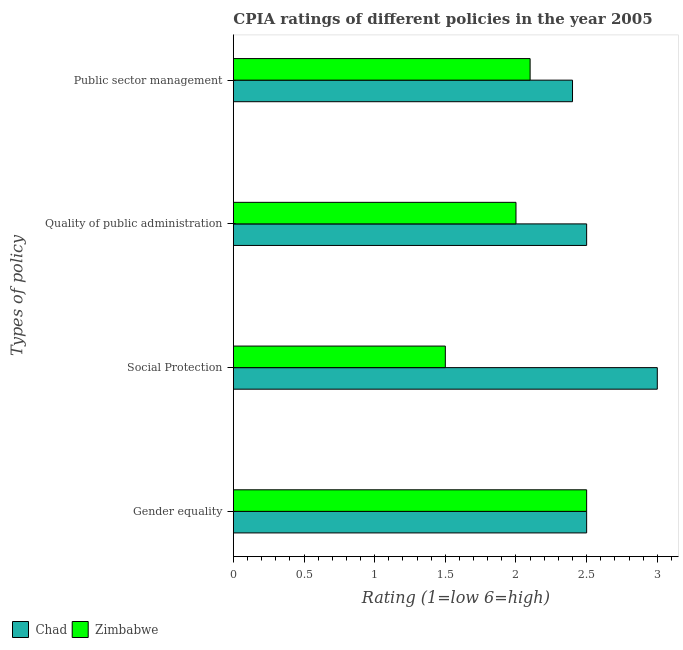How many different coloured bars are there?
Your answer should be very brief. 2. How many groups of bars are there?
Make the answer very short. 4. Are the number of bars per tick equal to the number of legend labels?
Provide a short and direct response. Yes. What is the label of the 1st group of bars from the top?
Offer a terse response. Public sector management. What is the cpia rating of public sector management in Chad?
Provide a succinct answer. 2.4. Across all countries, what is the maximum cpia rating of gender equality?
Your response must be concise. 2.5. Across all countries, what is the minimum cpia rating of gender equality?
Ensure brevity in your answer.  2.5. In which country was the cpia rating of gender equality maximum?
Offer a terse response. Chad. In which country was the cpia rating of gender equality minimum?
Make the answer very short. Chad. What is the total cpia rating of social protection in the graph?
Provide a succinct answer. 4.5. What is the difference between the cpia rating of social protection in Chad and that in Zimbabwe?
Make the answer very short. 1.5. What is the difference between the cpia rating of gender equality in Zimbabwe and the cpia rating of quality of public administration in Chad?
Ensure brevity in your answer.  0. What is the average cpia rating of quality of public administration per country?
Provide a succinct answer. 2.25. In how many countries, is the cpia rating of quality of public administration greater than 2.8 ?
Offer a terse response. 0. Is the cpia rating of public sector management in Chad less than that in Zimbabwe?
Make the answer very short. No. Is the difference between the cpia rating of public sector management in Zimbabwe and Chad greater than the difference between the cpia rating of gender equality in Zimbabwe and Chad?
Provide a succinct answer. No. In how many countries, is the cpia rating of quality of public administration greater than the average cpia rating of quality of public administration taken over all countries?
Make the answer very short. 1. Is the sum of the cpia rating of public sector management in Chad and Zimbabwe greater than the maximum cpia rating of quality of public administration across all countries?
Your response must be concise. Yes. What does the 2nd bar from the top in Gender equality represents?
Provide a short and direct response. Chad. What does the 2nd bar from the bottom in Quality of public administration represents?
Offer a very short reply. Zimbabwe. Is it the case that in every country, the sum of the cpia rating of gender equality and cpia rating of social protection is greater than the cpia rating of quality of public administration?
Your answer should be very brief. Yes. How many bars are there?
Provide a short and direct response. 8. Are the values on the major ticks of X-axis written in scientific E-notation?
Your answer should be very brief. No. Does the graph contain any zero values?
Keep it short and to the point. No. Does the graph contain grids?
Offer a very short reply. No. Where does the legend appear in the graph?
Offer a terse response. Bottom left. How many legend labels are there?
Provide a succinct answer. 2. How are the legend labels stacked?
Provide a short and direct response. Horizontal. What is the title of the graph?
Provide a short and direct response. CPIA ratings of different policies in the year 2005. What is the label or title of the Y-axis?
Your answer should be very brief. Types of policy. What is the Rating (1=low 6=high) in Chad in Gender equality?
Offer a terse response. 2.5. What is the Rating (1=low 6=high) in Zimbabwe in Gender equality?
Give a very brief answer. 2.5. What is the Rating (1=low 6=high) in Chad in Social Protection?
Offer a very short reply. 3. What is the Rating (1=low 6=high) of Chad in Public sector management?
Provide a succinct answer. 2.4. What is the Rating (1=low 6=high) in Zimbabwe in Public sector management?
Your answer should be very brief. 2.1. Across all Types of policy, what is the maximum Rating (1=low 6=high) in Chad?
Your answer should be compact. 3. Across all Types of policy, what is the maximum Rating (1=low 6=high) of Zimbabwe?
Offer a terse response. 2.5. Across all Types of policy, what is the minimum Rating (1=low 6=high) of Zimbabwe?
Offer a very short reply. 1.5. What is the total Rating (1=low 6=high) in Zimbabwe in the graph?
Your answer should be compact. 8.1. What is the difference between the Rating (1=low 6=high) of Zimbabwe in Gender equality and that in Social Protection?
Ensure brevity in your answer.  1. What is the difference between the Rating (1=low 6=high) in Chad in Gender equality and that in Quality of public administration?
Keep it short and to the point. 0. What is the difference between the Rating (1=low 6=high) in Zimbabwe in Gender equality and that in Quality of public administration?
Ensure brevity in your answer.  0.5. What is the difference between the Rating (1=low 6=high) of Chad in Gender equality and that in Public sector management?
Offer a very short reply. 0.1. What is the difference between the Rating (1=low 6=high) of Zimbabwe in Social Protection and that in Public sector management?
Keep it short and to the point. -0.6. What is the difference between the Rating (1=low 6=high) in Zimbabwe in Quality of public administration and that in Public sector management?
Keep it short and to the point. -0.1. What is the difference between the Rating (1=low 6=high) in Chad in Gender equality and the Rating (1=low 6=high) in Zimbabwe in Quality of public administration?
Make the answer very short. 0.5. What is the difference between the Rating (1=low 6=high) of Chad in Gender equality and the Rating (1=low 6=high) of Zimbabwe in Public sector management?
Keep it short and to the point. 0.4. What is the difference between the Rating (1=low 6=high) of Chad in Social Protection and the Rating (1=low 6=high) of Zimbabwe in Quality of public administration?
Offer a very short reply. 1. What is the difference between the Rating (1=low 6=high) of Chad in Quality of public administration and the Rating (1=low 6=high) of Zimbabwe in Public sector management?
Keep it short and to the point. 0.4. What is the average Rating (1=low 6=high) in Chad per Types of policy?
Keep it short and to the point. 2.6. What is the average Rating (1=low 6=high) of Zimbabwe per Types of policy?
Your answer should be compact. 2.02. What is the difference between the Rating (1=low 6=high) in Chad and Rating (1=low 6=high) in Zimbabwe in Gender equality?
Make the answer very short. 0. What is the difference between the Rating (1=low 6=high) in Chad and Rating (1=low 6=high) in Zimbabwe in Social Protection?
Your answer should be very brief. 1.5. What is the difference between the Rating (1=low 6=high) of Chad and Rating (1=low 6=high) of Zimbabwe in Quality of public administration?
Keep it short and to the point. 0.5. What is the ratio of the Rating (1=low 6=high) of Chad in Gender equality to that in Social Protection?
Ensure brevity in your answer.  0.83. What is the ratio of the Rating (1=low 6=high) in Chad in Gender equality to that in Public sector management?
Provide a succinct answer. 1.04. What is the ratio of the Rating (1=low 6=high) in Zimbabwe in Gender equality to that in Public sector management?
Provide a succinct answer. 1.19. What is the ratio of the Rating (1=low 6=high) of Chad in Social Protection to that in Quality of public administration?
Provide a succinct answer. 1.2. What is the ratio of the Rating (1=low 6=high) of Chad in Social Protection to that in Public sector management?
Offer a very short reply. 1.25. What is the ratio of the Rating (1=low 6=high) in Zimbabwe in Social Protection to that in Public sector management?
Keep it short and to the point. 0.71. What is the ratio of the Rating (1=low 6=high) of Chad in Quality of public administration to that in Public sector management?
Provide a short and direct response. 1.04. What is the ratio of the Rating (1=low 6=high) of Zimbabwe in Quality of public administration to that in Public sector management?
Your response must be concise. 0.95. What is the difference between the highest and the second highest Rating (1=low 6=high) in Zimbabwe?
Offer a very short reply. 0.4. What is the difference between the highest and the lowest Rating (1=low 6=high) of Chad?
Give a very brief answer. 0.6. What is the difference between the highest and the lowest Rating (1=low 6=high) of Zimbabwe?
Make the answer very short. 1. 